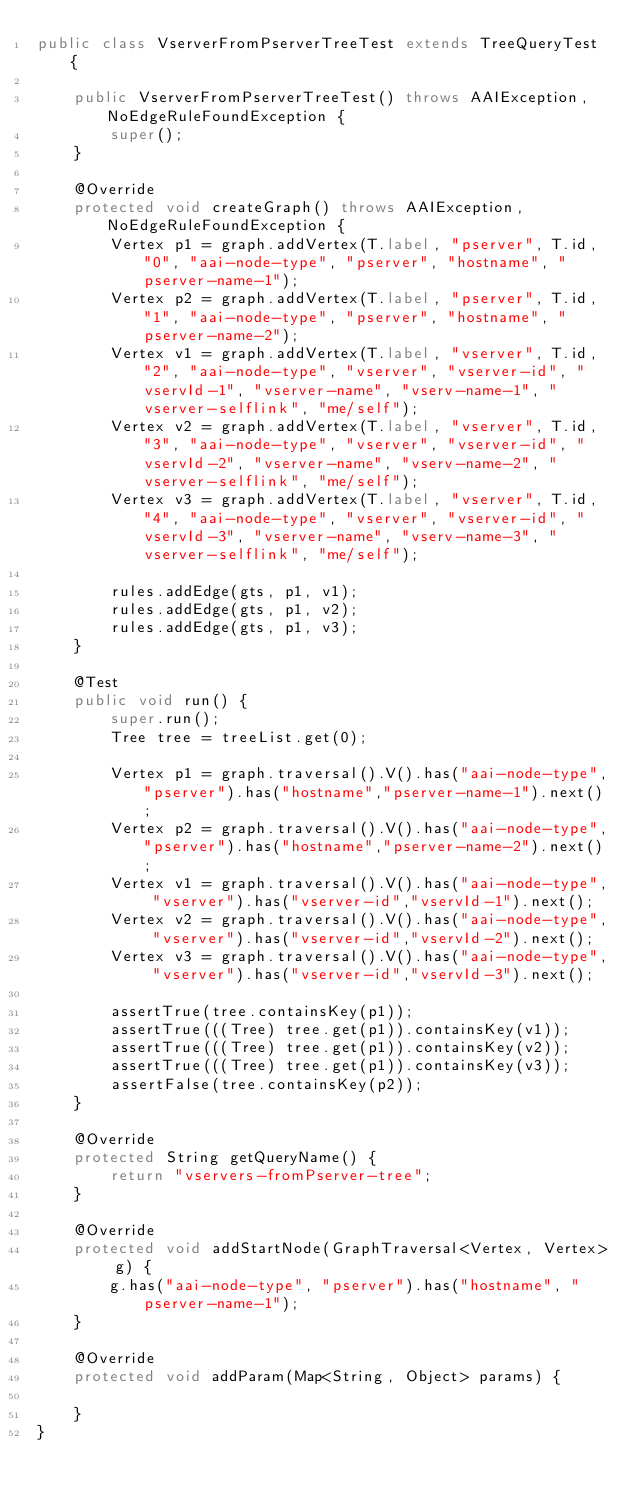Convert code to text. <code><loc_0><loc_0><loc_500><loc_500><_Java_>public class VserverFromPserverTreeTest extends TreeQueryTest {

    public VserverFromPserverTreeTest() throws AAIException, NoEdgeRuleFoundException {
        super();
    }

    @Override
    protected void createGraph() throws AAIException, NoEdgeRuleFoundException {
        Vertex p1 = graph.addVertex(T.label, "pserver", T.id, "0", "aai-node-type", "pserver", "hostname", "pserver-name-1");
        Vertex p2 = graph.addVertex(T.label, "pserver", T.id, "1", "aai-node-type", "pserver", "hostname", "pserver-name-2");
        Vertex v1 = graph.addVertex(T.label, "vserver", T.id, "2", "aai-node-type", "vserver", "vserver-id", "vservId-1", "vserver-name", "vserv-name-1", "vserver-selflink", "me/self");
        Vertex v2 = graph.addVertex(T.label, "vserver", T.id, "3", "aai-node-type", "vserver", "vserver-id", "vservId-2", "vserver-name", "vserv-name-2", "vserver-selflink", "me/self");
        Vertex v3 = graph.addVertex(T.label, "vserver", T.id, "4", "aai-node-type", "vserver", "vserver-id", "vservId-3", "vserver-name", "vserv-name-3", "vserver-selflink", "me/self");

        rules.addEdge(gts, p1, v1);
        rules.addEdge(gts, p1, v2);
        rules.addEdge(gts, p1, v3);
    }

    @Test
    public void run() {
        super.run();
        Tree tree = treeList.get(0);

        Vertex p1 = graph.traversal().V().has("aai-node-type","pserver").has("hostname","pserver-name-1").next();
        Vertex p2 = graph.traversal().V().has("aai-node-type","pserver").has("hostname","pserver-name-2").next();
        Vertex v1 = graph.traversal().V().has("aai-node-type", "vserver").has("vserver-id","vservId-1").next();
        Vertex v2 = graph.traversal().V().has("aai-node-type", "vserver").has("vserver-id","vservId-2").next();
        Vertex v3 = graph.traversal().V().has("aai-node-type", "vserver").has("vserver-id","vservId-3").next();

        assertTrue(tree.containsKey(p1));
        assertTrue(((Tree) tree.get(p1)).containsKey(v1));
        assertTrue(((Tree) tree.get(p1)).containsKey(v2));
        assertTrue(((Tree) tree.get(p1)).containsKey(v3));
        assertFalse(tree.containsKey(p2));
    }

    @Override
    protected String getQueryName() {
        return "vservers-fromPserver-tree";
    }

    @Override
    protected void addStartNode(GraphTraversal<Vertex, Vertex> g) {
        g.has("aai-node-type", "pserver").has("hostname", "pserver-name-1");
    }

    @Override
    protected void addParam(Map<String, Object> params) {

    }
}
</code> 